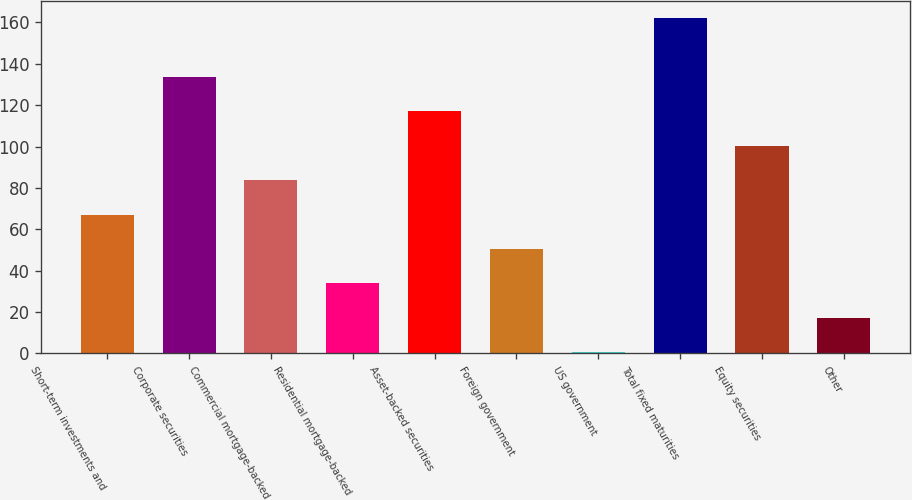Convert chart. <chart><loc_0><loc_0><loc_500><loc_500><bar_chart><fcel>Short-term investments and<fcel>Corporate securities<fcel>Commercial mortgage-backed<fcel>Residential mortgage-backed<fcel>Asset-backed securities<fcel>Foreign government<fcel>US government<fcel>Total fixed maturities<fcel>Equity securities<fcel>Other<nl><fcel>67.12<fcel>133.72<fcel>83.77<fcel>33.82<fcel>117.07<fcel>50.47<fcel>0.52<fcel>162<fcel>100.42<fcel>17.17<nl></chart> 